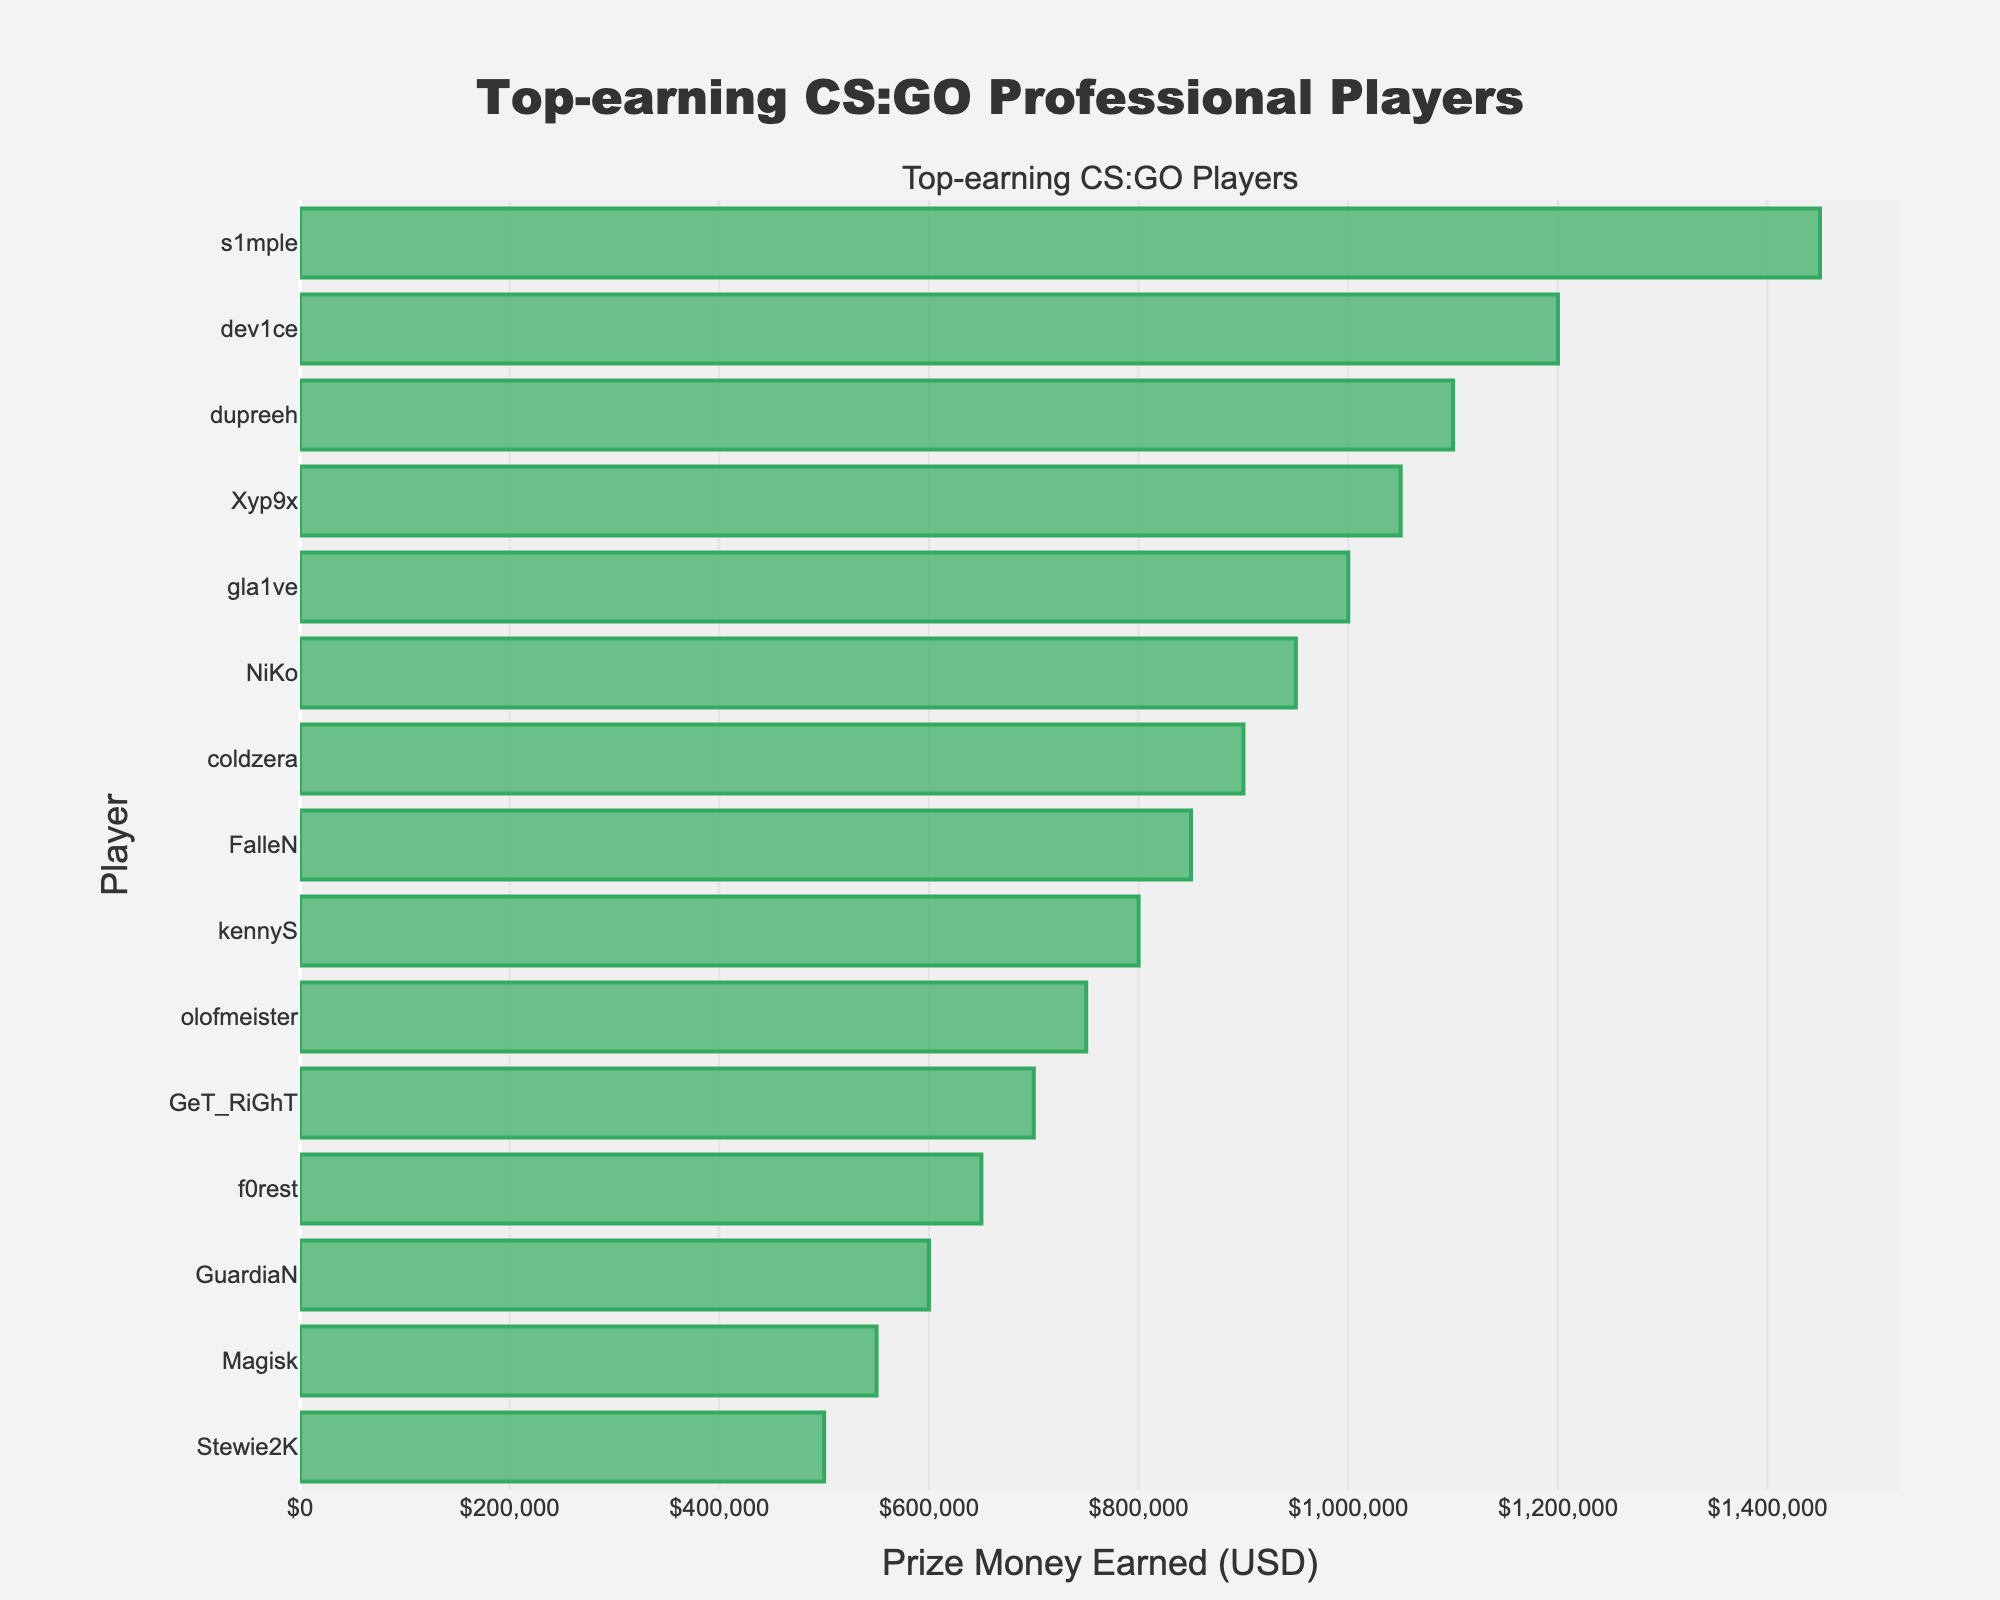Who is the top-earning CS:GO player? The player with the highest prize money earned will have the longest bar and be listed at the top of the y-axis. In this figure, that player is s1mple.
Answer: s1mple How much more has s1mple earned compared to NiKo? First, find the prize money earned by s1mple and NiKo from the figure. s1mple earned $1,450,000 and NiKo earned $950,000. The difference is calculated as $1,450,000 - $950,000 = $500,000.
Answer: $500,000 What is the total prize money earned by the top three earners? Add the prize money of the top three players: s1mple ($1,450,000), dev1ce ($1,200,000), and dupreeh ($1,100,000). So the total is $1,450,000 + $1,200,000 + $1,100,000 = $3,750,000.
Answer: $3,750,000 Who has earned more, Xyp9x or coldzera? Compare the length of the bars for Xyp9x and coldzera. Xyp9x has earned $1,050,000 and coldzera has earned $900,000. Xyp9x has earned more.
Answer: Xyp9x What is the average prize money earned by all players? Sum up the prize money earned by all players and divide it by the number of players. The total prize money is $15,800,000 / 15 = $1,053,333.
Answer: $1,053,333 Which players have earned between $800,000 and $1,000,000? Identify the players whose prize money falls in the range of $800,000 to $1,000,000. These players are NiKo ($950,000), coldzera ($900,000), and FalleN ($850,000).
Answer: NiKo, coldzera, FalleN How much has the 10th highest earner earned? Locate the 10th bar from the top on the y-axis. The 10th highest earner is olofmeister, who earned $750,000.
Answer: $750,000 What is the combined prize money of players earning less than $700,000? Identify and sum the prize money of players earning less than $700,000: f0rest ($650,000), GuardiaN ($600,000), Magisk ($550,000), and Stewie2K ($500,000). The total is $650,000 + $600,000 + $550,000 + $500,000 = $2,300,000.
Answer: $2,300,000 Is there any player with a prize money exactly $1,000,000? Scan the x-axis values to check for any bars that align exactly at $1,000,000. gla1ve is the player with $1,000,000.
Answer: gla1ve Who are the bottom three earners? Identify the last three players listed on the y-axis, which are Magisk ($550,000), and Stewie2K ($500,000).
Answer: Magisk, Stewie2K 